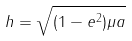<formula> <loc_0><loc_0><loc_500><loc_500>h = \sqrt { ( 1 - e ^ { 2 } ) \mu a }</formula> 